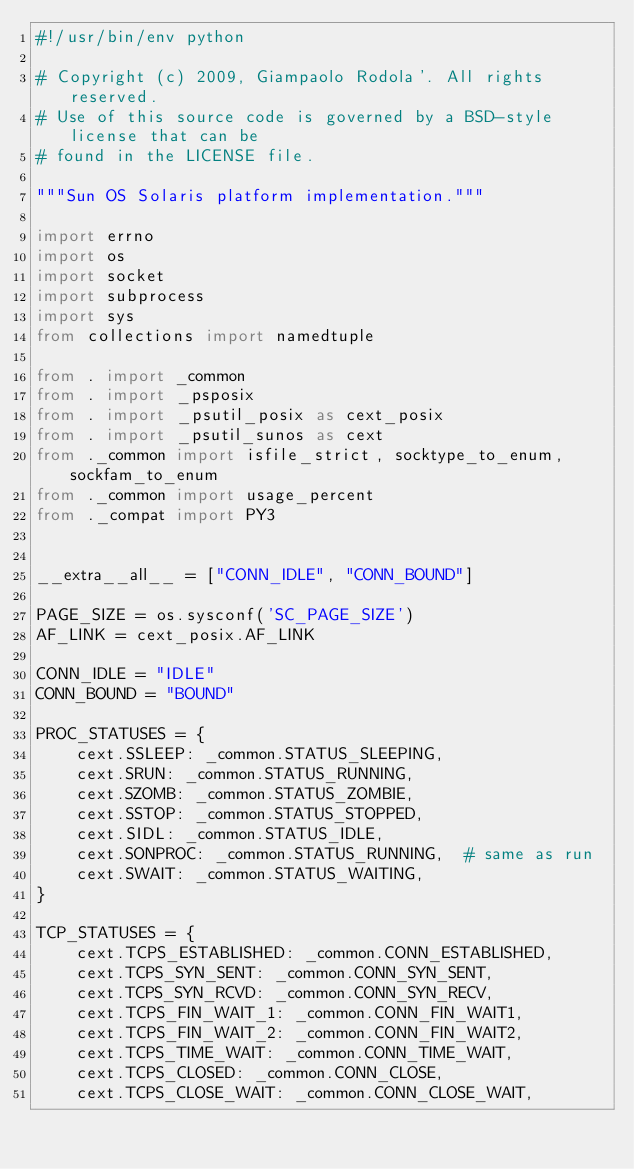<code> <loc_0><loc_0><loc_500><loc_500><_Python_>#!/usr/bin/env python

# Copyright (c) 2009, Giampaolo Rodola'. All rights reserved.
# Use of this source code is governed by a BSD-style license that can be
# found in the LICENSE file.

"""Sun OS Solaris platform implementation."""

import errno
import os
import socket
import subprocess
import sys
from collections import namedtuple

from . import _common
from . import _psposix
from . import _psutil_posix as cext_posix
from . import _psutil_sunos as cext
from ._common import isfile_strict, socktype_to_enum, sockfam_to_enum
from ._common import usage_percent
from ._compat import PY3


__extra__all__ = ["CONN_IDLE", "CONN_BOUND"]

PAGE_SIZE = os.sysconf('SC_PAGE_SIZE')
AF_LINK = cext_posix.AF_LINK

CONN_IDLE = "IDLE"
CONN_BOUND = "BOUND"

PROC_STATUSES = {
    cext.SSLEEP: _common.STATUS_SLEEPING,
    cext.SRUN: _common.STATUS_RUNNING,
    cext.SZOMB: _common.STATUS_ZOMBIE,
    cext.SSTOP: _common.STATUS_STOPPED,
    cext.SIDL: _common.STATUS_IDLE,
    cext.SONPROC: _common.STATUS_RUNNING,  # same as run
    cext.SWAIT: _common.STATUS_WAITING,
}

TCP_STATUSES = {
    cext.TCPS_ESTABLISHED: _common.CONN_ESTABLISHED,
    cext.TCPS_SYN_SENT: _common.CONN_SYN_SENT,
    cext.TCPS_SYN_RCVD: _common.CONN_SYN_RECV,
    cext.TCPS_FIN_WAIT_1: _common.CONN_FIN_WAIT1,
    cext.TCPS_FIN_WAIT_2: _common.CONN_FIN_WAIT2,
    cext.TCPS_TIME_WAIT: _common.CONN_TIME_WAIT,
    cext.TCPS_CLOSED: _common.CONN_CLOSE,
    cext.TCPS_CLOSE_WAIT: _common.CONN_CLOSE_WAIT,</code> 